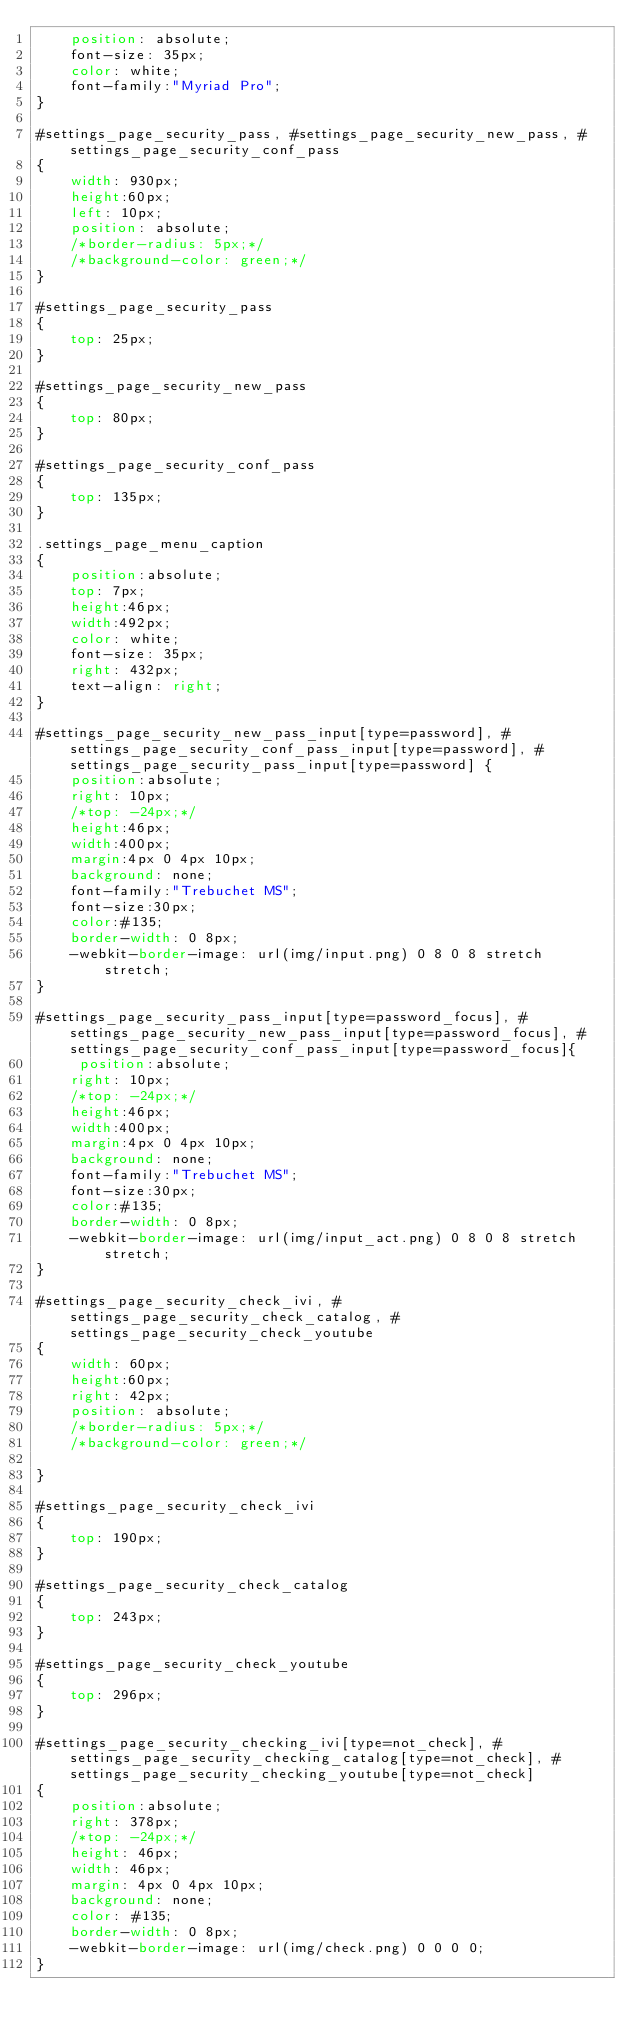Convert code to text. <code><loc_0><loc_0><loc_500><loc_500><_CSS_>	position: absolute;
	font-size: 35px;
	color: white;
	font-family:"Myriad Pro";
}

#settings_page_security_pass, #settings_page_security_new_pass, #settings_page_security_conf_pass
{
	width: 930px; 
	height:60px;
	left: 10px;		 
	position: absolute;	
	/*border-radius: 5px;*/
	/*background-color: green;*/
}

#settings_page_security_pass
{
	top: 25px;
}

#settings_page_security_new_pass
{
	top: 80px;
}

#settings_page_security_conf_pass
{
	top: 135px;
}

.settings_page_menu_caption
{
	position:absolute;
	top: 7px;
	height:46px; 
    width:492px;
    color: white;    
    font-size: 35px;
    right: 432px;
    text-align: right;
}

#settings_page_security_new_pass_input[type=password], #settings_page_security_conf_pass_input[type=password], #settings_page_security_pass_input[type=password] {
    position:absolute;
    right: 10px;
    /*top: -24px;*/
    height:46px; 
    width:400px; 
    margin:4px 0 4px 10px; 
    background: none; 
    font-family:"Trebuchet MS"; 
    font-size:30px; 
    color:#135; 
    border-width: 0 8px; 
    -webkit-border-image: url(img/input.png) 0 8 0 8 stretch stretch;
}

#settings_page_security_pass_input[type=password_focus], #settings_page_security_new_pass_input[type=password_focus], #settings_page_security_conf_pass_input[type=password_focus]{
     position:absolute;
    right: 10px;
    /*top: -24px;*/
    height:46px; 
    width:400px; 
    margin:4px 0 4px 10px; 
    background: none; 
    font-family:"Trebuchet MS"; 
    font-size:30px; 
    color:#135; 
    border-width: 0 8px; 
    -webkit-border-image: url(img/input_act.png) 0 8 0 8 stretch stretch;
}

#settings_page_security_check_ivi, #settings_page_security_check_catalog, #settings_page_security_check_youtube
{
	width: 60px; 
	height:60px;
	right: 42px;		 
	position: absolute;	
	/*border-radius: 5px;*/
	/*background-color: green;*/
	
}

#settings_page_security_check_ivi
{
	top: 190px;	
}

#settings_page_security_check_catalog
{
	top: 243px;	
}

#settings_page_security_check_youtube
{
	top: 296px;	
}

#settings_page_security_checking_ivi[type=not_check], #settings_page_security_checking_catalog[type=not_check], #settings_page_security_checking_youtube[type=not_check]
{
	position:absolute;
    right: 378px;
    /*top: -24px;*/
    height: 46px;
    width: 46px;
    margin: 4px 0 4px 10px;
    background: none;
    color: #135;
    border-width: 0 8px;
    -webkit-border-image: url(img/check.png) 0 0 0 0;
}
</code> 